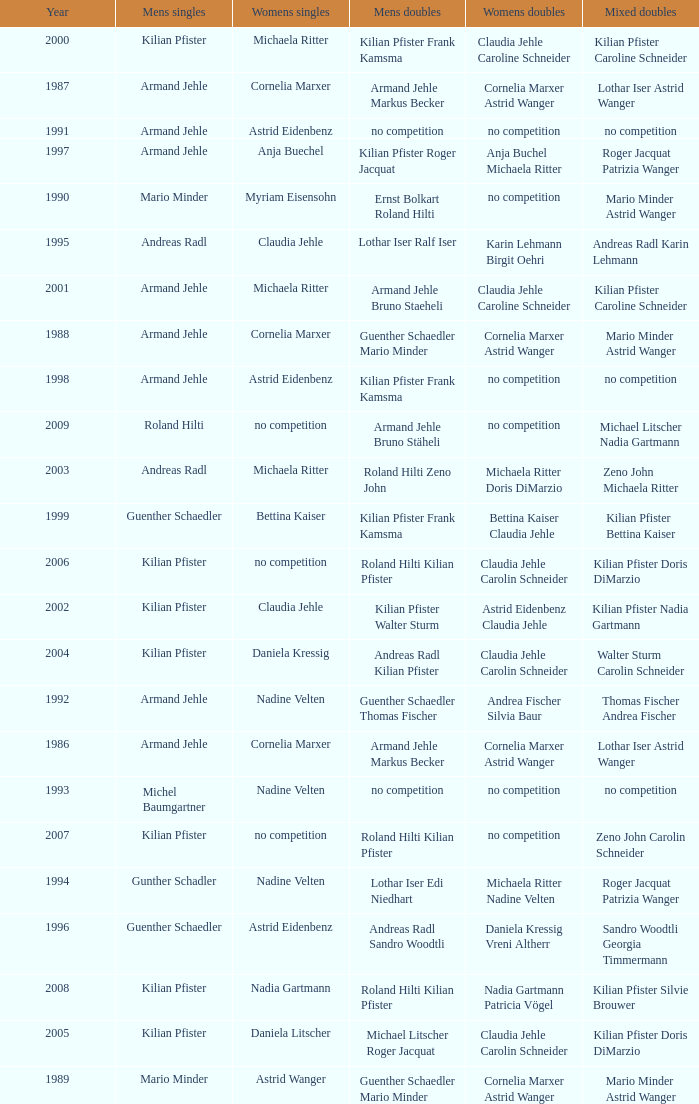In the year 2006, the womens singles had no competition and the mens doubles were roland hilti kilian pfister, what were the womens doubles Claudia Jehle Carolin Schneider. 